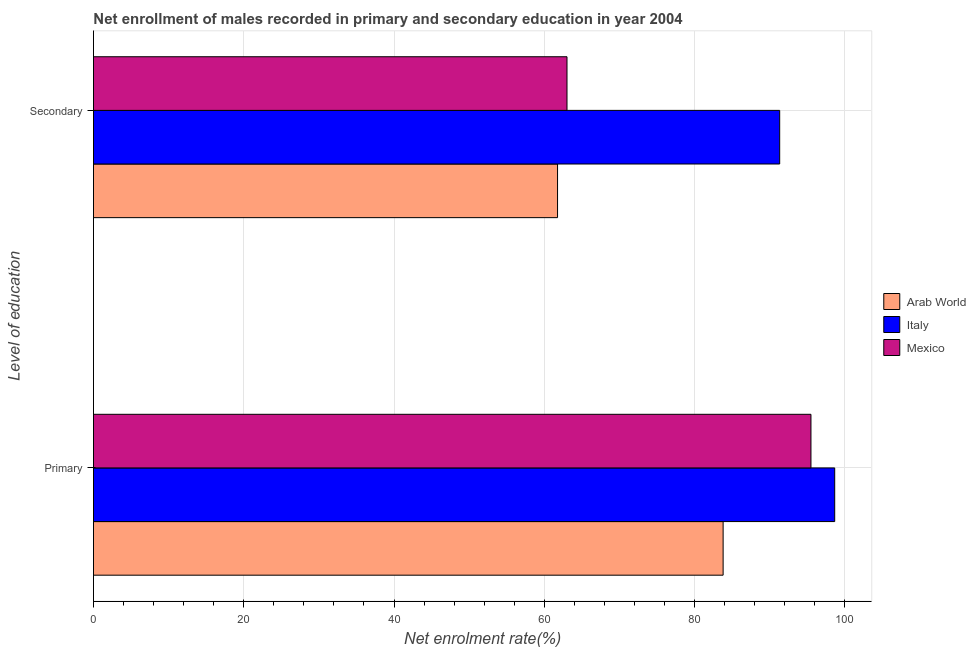How many groups of bars are there?
Your answer should be very brief. 2. Are the number of bars per tick equal to the number of legend labels?
Keep it short and to the point. Yes. How many bars are there on the 2nd tick from the top?
Ensure brevity in your answer.  3. How many bars are there on the 2nd tick from the bottom?
Your answer should be very brief. 3. What is the label of the 2nd group of bars from the top?
Your answer should be compact. Primary. What is the enrollment rate in secondary education in Mexico?
Ensure brevity in your answer.  63.02. Across all countries, what is the maximum enrollment rate in primary education?
Provide a succinct answer. 98.64. Across all countries, what is the minimum enrollment rate in secondary education?
Ensure brevity in your answer.  61.76. In which country was the enrollment rate in secondary education minimum?
Offer a very short reply. Arab World. What is the total enrollment rate in secondary education in the graph?
Your answer should be very brief. 216.1. What is the difference between the enrollment rate in primary education in Arab World and that in Italy?
Keep it short and to the point. -14.85. What is the difference between the enrollment rate in secondary education in Arab World and the enrollment rate in primary education in Italy?
Keep it short and to the point. -36.88. What is the average enrollment rate in secondary education per country?
Provide a succinct answer. 72.03. What is the difference between the enrollment rate in secondary education and enrollment rate in primary education in Italy?
Keep it short and to the point. -7.32. In how many countries, is the enrollment rate in secondary education greater than 28 %?
Give a very brief answer. 3. What is the ratio of the enrollment rate in secondary education in Italy to that in Mexico?
Make the answer very short. 1.45. Is the enrollment rate in primary education in Mexico less than that in Italy?
Ensure brevity in your answer.  Yes. In how many countries, is the enrollment rate in primary education greater than the average enrollment rate in primary education taken over all countries?
Your answer should be very brief. 2. What does the 2nd bar from the top in Secondary represents?
Make the answer very short. Italy. What does the 2nd bar from the bottom in Secondary represents?
Provide a succinct answer. Italy. How many bars are there?
Ensure brevity in your answer.  6. Are all the bars in the graph horizontal?
Give a very brief answer. Yes. How many countries are there in the graph?
Provide a succinct answer. 3. Does the graph contain grids?
Provide a short and direct response. Yes. Where does the legend appear in the graph?
Your answer should be compact. Center right. What is the title of the graph?
Provide a short and direct response. Net enrollment of males recorded in primary and secondary education in year 2004. Does "Monaco" appear as one of the legend labels in the graph?
Your answer should be compact. No. What is the label or title of the X-axis?
Ensure brevity in your answer.  Net enrolment rate(%). What is the label or title of the Y-axis?
Make the answer very short. Level of education. What is the Net enrolment rate(%) of Arab World in Primary?
Offer a terse response. 83.79. What is the Net enrolment rate(%) of Italy in Primary?
Your answer should be compact. 98.64. What is the Net enrolment rate(%) of Mexico in Primary?
Your answer should be very brief. 95.48. What is the Net enrolment rate(%) of Arab World in Secondary?
Give a very brief answer. 61.76. What is the Net enrolment rate(%) of Italy in Secondary?
Make the answer very short. 91.32. What is the Net enrolment rate(%) in Mexico in Secondary?
Give a very brief answer. 63.02. Across all Level of education, what is the maximum Net enrolment rate(%) in Arab World?
Keep it short and to the point. 83.79. Across all Level of education, what is the maximum Net enrolment rate(%) of Italy?
Keep it short and to the point. 98.64. Across all Level of education, what is the maximum Net enrolment rate(%) in Mexico?
Offer a terse response. 95.48. Across all Level of education, what is the minimum Net enrolment rate(%) of Arab World?
Offer a terse response. 61.76. Across all Level of education, what is the minimum Net enrolment rate(%) in Italy?
Make the answer very short. 91.32. Across all Level of education, what is the minimum Net enrolment rate(%) of Mexico?
Ensure brevity in your answer.  63.02. What is the total Net enrolment rate(%) in Arab World in the graph?
Provide a short and direct response. 145.55. What is the total Net enrolment rate(%) in Italy in the graph?
Provide a succinct answer. 189.96. What is the total Net enrolment rate(%) in Mexico in the graph?
Offer a terse response. 158.5. What is the difference between the Net enrolment rate(%) in Arab World in Primary and that in Secondary?
Keep it short and to the point. 22.03. What is the difference between the Net enrolment rate(%) of Italy in Primary and that in Secondary?
Offer a very short reply. 7.32. What is the difference between the Net enrolment rate(%) of Mexico in Primary and that in Secondary?
Provide a succinct answer. 32.47. What is the difference between the Net enrolment rate(%) of Arab World in Primary and the Net enrolment rate(%) of Italy in Secondary?
Your answer should be very brief. -7.53. What is the difference between the Net enrolment rate(%) of Arab World in Primary and the Net enrolment rate(%) of Mexico in Secondary?
Your answer should be very brief. 20.78. What is the difference between the Net enrolment rate(%) of Italy in Primary and the Net enrolment rate(%) of Mexico in Secondary?
Provide a short and direct response. 35.63. What is the average Net enrolment rate(%) in Arab World per Level of education?
Make the answer very short. 72.78. What is the average Net enrolment rate(%) in Italy per Level of education?
Your answer should be very brief. 94.98. What is the average Net enrolment rate(%) of Mexico per Level of education?
Give a very brief answer. 79.25. What is the difference between the Net enrolment rate(%) in Arab World and Net enrolment rate(%) in Italy in Primary?
Your response must be concise. -14.85. What is the difference between the Net enrolment rate(%) in Arab World and Net enrolment rate(%) in Mexico in Primary?
Your answer should be very brief. -11.69. What is the difference between the Net enrolment rate(%) in Italy and Net enrolment rate(%) in Mexico in Primary?
Ensure brevity in your answer.  3.16. What is the difference between the Net enrolment rate(%) in Arab World and Net enrolment rate(%) in Italy in Secondary?
Your answer should be compact. -29.56. What is the difference between the Net enrolment rate(%) in Arab World and Net enrolment rate(%) in Mexico in Secondary?
Make the answer very short. -1.26. What is the difference between the Net enrolment rate(%) of Italy and Net enrolment rate(%) of Mexico in Secondary?
Offer a terse response. 28.3. What is the ratio of the Net enrolment rate(%) in Arab World in Primary to that in Secondary?
Offer a terse response. 1.36. What is the ratio of the Net enrolment rate(%) in Italy in Primary to that in Secondary?
Ensure brevity in your answer.  1.08. What is the ratio of the Net enrolment rate(%) in Mexico in Primary to that in Secondary?
Provide a short and direct response. 1.52. What is the difference between the highest and the second highest Net enrolment rate(%) of Arab World?
Offer a very short reply. 22.03. What is the difference between the highest and the second highest Net enrolment rate(%) of Italy?
Your answer should be very brief. 7.32. What is the difference between the highest and the second highest Net enrolment rate(%) of Mexico?
Your response must be concise. 32.47. What is the difference between the highest and the lowest Net enrolment rate(%) of Arab World?
Give a very brief answer. 22.03. What is the difference between the highest and the lowest Net enrolment rate(%) of Italy?
Ensure brevity in your answer.  7.32. What is the difference between the highest and the lowest Net enrolment rate(%) of Mexico?
Make the answer very short. 32.47. 